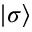<formula> <loc_0><loc_0><loc_500><loc_500>| \sigma \rangle</formula> 